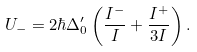Convert formula to latex. <formula><loc_0><loc_0><loc_500><loc_500>U _ { - } = 2 \hbar { \Delta } _ { 0 } ^ { \prime } \left ( \frac { I ^ { - } } { I } + \frac { I ^ { + } } { 3 I } \right ) .</formula> 